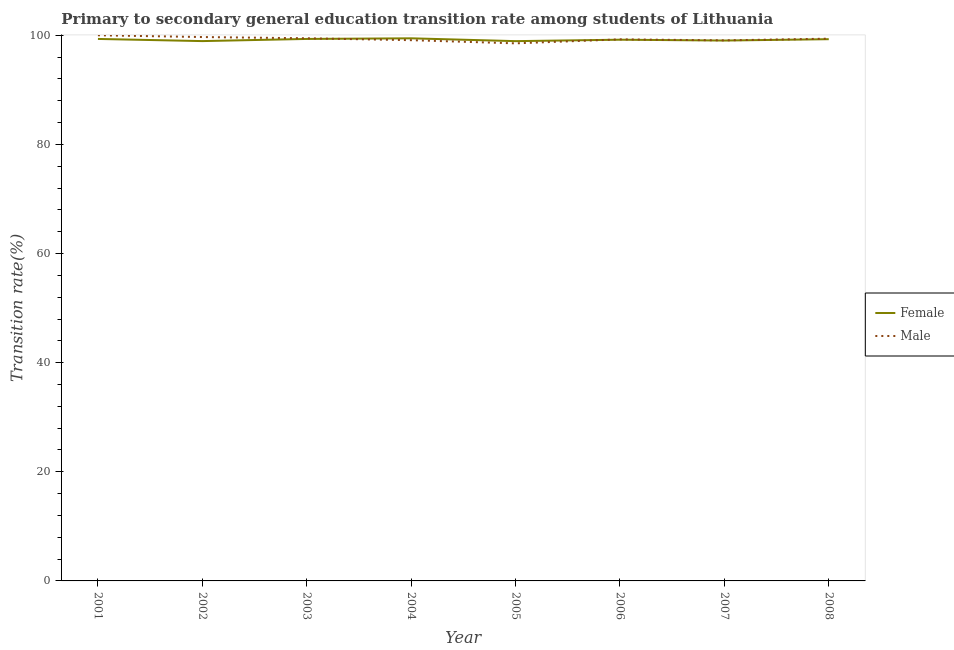How many different coloured lines are there?
Offer a very short reply. 2. Does the line corresponding to transition rate among female students intersect with the line corresponding to transition rate among male students?
Make the answer very short. Yes. Is the number of lines equal to the number of legend labels?
Offer a very short reply. Yes. What is the transition rate among female students in 2004?
Give a very brief answer. 99.44. Across all years, what is the maximum transition rate among female students?
Your response must be concise. 99.44. Across all years, what is the minimum transition rate among female students?
Provide a succinct answer. 98.93. In which year was the transition rate among male students maximum?
Your answer should be very brief. 2001. In which year was the transition rate among male students minimum?
Your response must be concise. 2005. What is the total transition rate among female students in the graph?
Ensure brevity in your answer.  793.47. What is the difference between the transition rate among male students in 2002 and that in 2008?
Your answer should be very brief. 0.3. What is the difference between the transition rate among female students in 2001 and the transition rate among male students in 2002?
Your answer should be very brief. -0.35. What is the average transition rate among female students per year?
Make the answer very short. 99.18. In the year 2001, what is the difference between the transition rate among female students and transition rate among male students?
Offer a terse response. -0.67. In how many years, is the transition rate among male students greater than 56 %?
Your answer should be compact. 8. What is the ratio of the transition rate among male students in 2001 to that in 2008?
Give a very brief answer. 1.01. Is the difference between the transition rate among male students in 2007 and 2008 greater than the difference between the transition rate among female students in 2007 and 2008?
Provide a succinct answer. No. What is the difference between the highest and the second highest transition rate among female students?
Ensure brevity in your answer.  0.11. What is the difference between the highest and the lowest transition rate among male students?
Provide a succinct answer. 1.48. Is the transition rate among female students strictly greater than the transition rate among male students over the years?
Give a very brief answer. No. How many years are there in the graph?
Ensure brevity in your answer.  8. Does the graph contain grids?
Provide a short and direct response. No. Where does the legend appear in the graph?
Your answer should be compact. Center right. How many legend labels are there?
Make the answer very short. 2. How are the legend labels stacked?
Offer a terse response. Vertical. What is the title of the graph?
Keep it short and to the point. Primary to secondary general education transition rate among students of Lithuania. What is the label or title of the X-axis?
Offer a terse response. Year. What is the label or title of the Y-axis?
Your response must be concise. Transition rate(%). What is the Transition rate(%) of Female in 2001?
Provide a succinct answer. 99.33. What is the Transition rate(%) of Male in 2001?
Ensure brevity in your answer.  100. What is the Transition rate(%) of Female in 2002?
Keep it short and to the point. 98.93. What is the Transition rate(%) in Male in 2002?
Keep it short and to the point. 99.68. What is the Transition rate(%) in Female in 2003?
Your answer should be very brief. 99.33. What is the Transition rate(%) in Male in 2003?
Give a very brief answer. 99.45. What is the Transition rate(%) of Female in 2004?
Offer a very short reply. 99.44. What is the Transition rate(%) in Male in 2004?
Keep it short and to the point. 99.1. What is the Transition rate(%) in Female in 2005?
Make the answer very short. 98.93. What is the Transition rate(%) of Male in 2005?
Your answer should be compact. 98.52. What is the Transition rate(%) of Female in 2006?
Your response must be concise. 99.19. What is the Transition rate(%) of Male in 2006?
Your answer should be very brief. 99.25. What is the Transition rate(%) in Female in 2007?
Your answer should be very brief. 99.03. What is the Transition rate(%) of Male in 2007?
Offer a very short reply. 99.07. What is the Transition rate(%) in Female in 2008?
Offer a very short reply. 99.28. What is the Transition rate(%) of Male in 2008?
Ensure brevity in your answer.  99.38. Across all years, what is the maximum Transition rate(%) in Female?
Make the answer very short. 99.44. Across all years, what is the minimum Transition rate(%) in Female?
Ensure brevity in your answer.  98.93. Across all years, what is the minimum Transition rate(%) of Male?
Provide a short and direct response. 98.52. What is the total Transition rate(%) in Female in the graph?
Offer a very short reply. 793.47. What is the total Transition rate(%) of Male in the graph?
Give a very brief answer. 794.45. What is the difference between the Transition rate(%) in Female in 2001 and that in 2002?
Offer a very short reply. 0.4. What is the difference between the Transition rate(%) in Male in 2001 and that in 2002?
Your response must be concise. 0.32. What is the difference between the Transition rate(%) of Female in 2001 and that in 2003?
Your answer should be very brief. -0. What is the difference between the Transition rate(%) of Male in 2001 and that in 2003?
Offer a very short reply. 0.55. What is the difference between the Transition rate(%) of Female in 2001 and that in 2004?
Your answer should be compact. -0.11. What is the difference between the Transition rate(%) in Male in 2001 and that in 2004?
Provide a succinct answer. 0.9. What is the difference between the Transition rate(%) in Female in 2001 and that in 2005?
Ensure brevity in your answer.  0.4. What is the difference between the Transition rate(%) in Male in 2001 and that in 2005?
Your response must be concise. 1.48. What is the difference between the Transition rate(%) of Female in 2001 and that in 2006?
Give a very brief answer. 0.14. What is the difference between the Transition rate(%) of Male in 2001 and that in 2006?
Offer a terse response. 0.75. What is the difference between the Transition rate(%) in Female in 2001 and that in 2007?
Make the answer very short. 0.3. What is the difference between the Transition rate(%) of Male in 2001 and that in 2007?
Your response must be concise. 0.93. What is the difference between the Transition rate(%) in Female in 2001 and that in 2008?
Ensure brevity in your answer.  0.05. What is the difference between the Transition rate(%) in Male in 2001 and that in 2008?
Provide a succinct answer. 0.62. What is the difference between the Transition rate(%) of Female in 2002 and that in 2003?
Offer a very short reply. -0.4. What is the difference between the Transition rate(%) in Male in 2002 and that in 2003?
Ensure brevity in your answer.  0.23. What is the difference between the Transition rate(%) of Female in 2002 and that in 2004?
Offer a terse response. -0.51. What is the difference between the Transition rate(%) in Male in 2002 and that in 2004?
Make the answer very short. 0.57. What is the difference between the Transition rate(%) of Female in 2002 and that in 2005?
Make the answer very short. 0.01. What is the difference between the Transition rate(%) of Male in 2002 and that in 2005?
Ensure brevity in your answer.  1.16. What is the difference between the Transition rate(%) in Female in 2002 and that in 2006?
Ensure brevity in your answer.  -0.26. What is the difference between the Transition rate(%) of Male in 2002 and that in 2006?
Make the answer very short. 0.43. What is the difference between the Transition rate(%) of Female in 2002 and that in 2007?
Your response must be concise. -0.1. What is the difference between the Transition rate(%) in Male in 2002 and that in 2007?
Ensure brevity in your answer.  0.61. What is the difference between the Transition rate(%) in Female in 2002 and that in 2008?
Your answer should be compact. -0.35. What is the difference between the Transition rate(%) of Male in 2002 and that in 2008?
Ensure brevity in your answer.  0.3. What is the difference between the Transition rate(%) of Female in 2003 and that in 2004?
Offer a terse response. -0.11. What is the difference between the Transition rate(%) in Male in 2003 and that in 2004?
Offer a terse response. 0.35. What is the difference between the Transition rate(%) in Female in 2003 and that in 2005?
Make the answer very short. 0.41. What is the difference between the Transition rate(%) in Male in 2003 and that in 2005?
Your response must be concise. 0.93. What is the difference between the Transition rate(%) in Female in 2003 and that in 2006?
Keep it short and to the point. 0.14. What is the difference between the Transition rate(%) in Male in 2003 and that in 2006?
Your answer should be very brief. 0.2. What is the difference between the Transition rate(%) in Female in 2003 and that in 2007?
Your answer should be compact. 0.3. What is the difference between the Transition rate(%) in Male in 2003 and that in 2007?
Offer a very short reply. 0.38. What is the difference between the Transition rate(%) of Female in 2003 and that in 2008?
Your answer should be compact. 0.05. What is the difference between the Transition rate(%) in Male in 2003 and that in 2008?
Offer a very short reply. 0.07. What is the difference between the Transition rate(%) of Female in 2004 and that in 2005?
Give a very brief answer. 0.52. What is the difference between the Transition rate(%) in Male in 2004 and that in 2005?
Offer a very short reply. 0.58. What is the difference between the Transition rate(%) in Female in 2004 and that in 2006?
Ensure brevity in your answer.  0.25. What is the difference between the Transition rate(%) in Male in 2004 and that in 2006?
Offer a very short reply. -0.15. What is the difference between the Transition rate(%) in Female in 2004 and that in 2007?
Offer a very short reply. 0.41. What is the difference between the Transition rate(%) in Male in 2004 and that in 2007?
Provide a short and direct response. 0.03. What is the difference between the Transition rate(%) of Female in 2004 and that in 2008?
Give a very brief answer. 0.16. What is the difference between the Transition rate(%) of Male in 2004 and that in 2008?
Ensure brevity in your answer.  -0.28. What is the difference between the Transition rate(%) in Female in 2005 and that in 2006?
Your response must be concise. -0.26. What is the difference between the Transition rate(%) in Male in 2005 and that in 2006?
Your answer should be compact. -0.73. What is the difference between the Transition rate(%) of Female in 2005 and that in 2007?
Keep it short and to the point. -0.11. What is the difference between the Transition rate(%) in Male in 2005 and that in 2007?
Your response must be concise. -0.55. What is the difference between the Transition rate(%) of Female in 2005 and that in 2008?
Provide a succinct answer. -0.36. What is the difference between the Transition rate(%) in Male in 2005 and that in 2008?
Offer a very short reply. -0.86. What is the difference between the Transition rate(%) in Female in 2006 and that in 2007?
Your answer should be very brief. 0.16. What is the difference between the Transition rate(%) in Male in 2006 and that in 2007?
Ensure brevity in your answer.  0.18. What is the difference between the Transition rate(%) in Female in 2006 and that in 2008?
Provide a succinct answer. -0.09. What is the difference between the Transition rate(%) of Male in 2006 and that in 2008?
Give a very brief answer. -0.13. What is the difference between the Transition rate(%) of Female in 2007 and that in 2008?
Offer a terse response. -0.25. What is the difference between the Transition rate(%) of Male in 2007 and that in 2008?
Offer a very short reply. -0.31. What is the difference between the Transition rate(%) of Female in 2001 and the Transition rate(%) of Male in 2002?
Your answer should be compact. -0.35. What is the difference between the Transition rate(%) in Female in 2001 and the Transition rate(%) in Male in 2003?
Ensure brevity in your answer.  -0.12. What is the difference between the Transition rate(%) of Female in 2001 and the Transition rate(%) of Male in 2004?
Your response must be concise. 0.23. What is the difference between the Transition rate(%) of Female in 2001 and the Transition rate(%) of Male in 2005?
Make the answer very short. 0.81. What is the difference between the Transition rate(%) of Female in 2001 and the Transition rate(%) of Male in 2006?
Your answer should be very brief. 0.08. What is the difference between the Transition rate(%) in Female in 2001 and the Transition rate(%) in Male in 2007?
Provide a succinct answer. 0.26. What is the difference between the Transition rate(%) in Female in 2001 and the Transition rate(%) in Male in 2008?
Offer a terse response. -0.05. What is the difference between the Transition rate(%) of Female in 2002 and the Transition rate(%) of Male in 2003?
Your response must be concise. -0.52. What is the difference between the Transition rate(%) in Female in 2002 and the Transition rate(%) in Male in 2004?
Your response must be concise. -0.17. What is the difference between the Transition rate(%) in Female in 2002 and the Transition rate(%) in Male in 2005?
Provide a short and direct response. 0.41. What is the difference between the Transition rate(%) in Female in 2002 and the Transition rate(%) in Male in 2006?
Provide a short and direct response. -0.32. What is the difference between the Transition rate(%) in Female in 2002 and the Transition rate(%) in Male in 2007?
Make the answer very short. -0.13. What is the difference between the Transition rate(%) in Female in 2002 and the Transition rate(%) in Male in 2008?
Give a very brief answer. -0.44. What is the difference between the Transition rate(%) of Female in 2003 and the Transition rate(%) of Male in 2004?
Provide a succinct answer. 0.23. What is the difference between the Transition rate(%) of Female in 2003 and the Transition rate(%) of Male in 2005?
Provide a short and direct response. 0.81. What is the difference between the Transition rate(%) of Female in 2003 and the Transition rate(%) of Male in 2006?
Your answer should be compact. 0.08. What is the difference between the Transition rate(%) in Female in 2003 and the Transition rate(%) in Male in 2007?
Give a very brief answer. 0.26. What is the difference between the Transition rate(%) of Female in 2003 and the Transition rate(%) of Male in 2008?
Ensure brevity in your answer.  -0.05. What is the difference between the Transition rate(%) of Female in 2004 and the Transition rate(%) of Male in 2005?
Your response must be concise. 0.92. What is the difference between the Transition rate(%) of Female in 2004 and the Transition rate(%) of Male in 2006?
Your response must be concise. 0.19. What is the difference between the Transition rate(%) of Female in 2004 and the Transition rate(%) of Male in 2007?
Provide a short and direct response. 0.38. What is the difference between the Transition rate(%) in Female in 2004 and the Transition rate(%) in Male in 2008?
Make the answer very short. 0.06. What is the difference between the Transition rate(%) of Female in 2005 and the Transition rate(%) of Male in 2006?
Ensure brevity in your answer.  -0.33. What is the difference between the Transition rate(%) of Female in 2005 and the Transition rate(%) of Male in 2007?
Your response must be concise. -0.14. What is the difference between the Transition rate(%) in Female in 2005 and the Transition rate(%) in Male in 2008?
Keep it short and to the point. -0.45. What is the difference between the Transition rate(%) of Female in 2006 and the Transition rate(%) of Male in 2007?
Offer a very short reply. 0.12. What is the difference between the Transition rate(%) in Female in 2006 and the Transition rate(%) in Male in 2008?
Provide a succinct answer. -0.19. What is the difference between the Transition rate(%) in Female in 2007 and the Transition rate(%) in Male in 2008?
Keep it short and to the point. -0.35. What is the average Transition rate(%) of Female per year?
Your answer should be compact. 99.18. What is the average Transition rate(%) of Male per year?
Keep it short and to the point. 99.31. In the year 2001, what is the difference between the Transition rate(%) in Female and Transition rate(%) in Male?
Provide a short and direct response. -0.67. In the year 2002, what is the difference between the Transition rate(%) in Female and Transition rate(%) in Male?
Offer a terse response. -0.74. In the year 2003, what is the difference between the Transition rate(%) of Female and Transition rate(%) of Male?
Make the answer very short. -0.12. In the year 2004, what is the difference between the Transition rate(%) of Female and Transition rate(%) of Male?
Your response must be concise. 0.34. In the year 2005, what is the difference between the Transition rate(%) in Female and Transition rate(%) in Male?
Keep it short and to the point. 0.4. In the year 2006, what is the difference between the Transition rate(%) in Female and Transition rate(%) in Male?
Your answer should be compact. -0.06. In the year 2007, what is the difference between the Transition rate(%) of Female and Transition rate(%) of Male?
Provide a short and direct response. -0.03. In the year 2008, what is the difference between the Transition rate(%) of Female and Transition rate(%) of Male?
Your answer should be very brief. -0.1. What is the ratio of the Transition rate(%) in Female in 2001 to that in 2002?
Give a very brief answer. 1. What is the ratio of the Transition rate(%) of Female in 2001 to that in 2003?
Offer a very short reply. 1. What is the ratio of the Transition rate(%) of Female in 2001 to that in 2004?
Provide a succinct answer. 1. What is the ratio of the Transition rate(%) of Male in 2001 to that in 2004?
Keep it short and to the point. 1.01. What is the ratio of the Transition rate(%) in Female in 2001 to that in 2006?
Offer a very short reply. 1. What is the ratio of the Transition rate(%) in Male in 2001 to that in 2006?
Your answer should be compact. 1.01. What is the ratio of the Transition rate(%) of Male in 2001 to that in 2007?
Offer a very short reply. 1.01. What is the ratio of the Transition rate(%) of Male in 2001 to that in 2008?
Provide a succinct answer. 1.01. What is the ratio of the Transition rate(%) of Male in 2002 to that in 2003?
Provide a short and direct response. 1. What is the ratio of the Transition rate(%) of Female in 2002 to that in 2004?
Offer a terse response. 0.99. What is the ratio of the Transition rate(%) in Male in 2002 to that in 2004?
Your answer should be very brief. 1.01. What is the ratio of the Transition rate(%) in Male in 2002 to that in 2005?
Offer a terse response. 1.01. What is the ratio of the Transition rate(%) in Male in 2002 to that in 2006?
Ensure brevity in your answer.  1. What is the ratio of the Transition rate(%) in Male in 2002 to that in 2007?
Your answer should be compact. 1.01. What is the ratio of the Transition rate(%) in Female in 2003 to that in 2004?
Give a very brief answer. 1. What is the ratio of the Transition rate(%) of Female in 2003 to that in 2005?
Offer a terse response. 1. What is the ratio of the Transition rate(%) of Male in 2003 to that in 2005?
Ensure brevity in your answer.  1.01. What is the ratio of the Transition rate(%) in Female in 2003 to that in 2006?
Your response must be concise. 1. What is the ratio of the Transition rate(%) in Female in 2003 to that in 2007?
Give a very brief answer. 1. What is the ratio of the Transition rate(%) of Male in 2003 to that in 2007?
Keep it short and to the point. 1. What is the ratio of the Transition rate(%) in Female in 2003 to that in 2008?
Ensure brevity in your answer.  1. What is the ratio of the Transition rate(%) of Male in 2003 to that in 2008?
Keep it short and to the point. 1. What is the ratio of the Transition rate(%) of Female in 2004 to that in 2005?
Offer a terse response. 1.01. What is the ratio of the Transition rate(%) of Male in 2004 to that in 2005?
Offer a very short reply. 1.01. What is the ratio of the Transition rate(%) in Female in 2004 to that in 2006?
Offer a very short reply. 1. What is the ratio of the Transition rate(%) in Male in 2004 to that in 2007?
Give a very brief answer. 1. What is the ratio of the Transition rate(%) of Female in 2004 to that in 2008?
Give a very brief answer. 1. What is the ratio of the Transition rate(%) in Male in 2004 to that in 2008?
Your answer should be very brief. 1. What is the ratio of the Transition rate(%) in Male in 2005 to that in 2007?
Make the answer very short. 0.99. What is the ratio of the Transition rate(%) of Male in 2006 to that in 2007?
Ensure brevity in your answer.  1. What is the ratio of the Transition rate(%) in Female in 2006 to that in 2008?
Provide a short and direct response. 1. What is the ratio of the Transition rate(%) in Male in 2006 to that in 2008?
Your answer should be very brief. 1. What is the ratio of the Transition rate(%) in Male in 2007 to that in 2008?
Offer a very short reply. 1. What is the difference between the highest and the second highest Transition rate(%) in Female?
Your response must be concise. 0.11. What is the difference between the highest and the second highest Transition rate(%) in Male?
Make the answer very short. 0.32. What is the difference between the highest and the lowest Transition rate(%) of Female?
Your answer should be very brief. 0.52. What is the difference between the highest and the lowest Transition rate(%) in Male?
Ensure brevity in your answer.  1.48. 